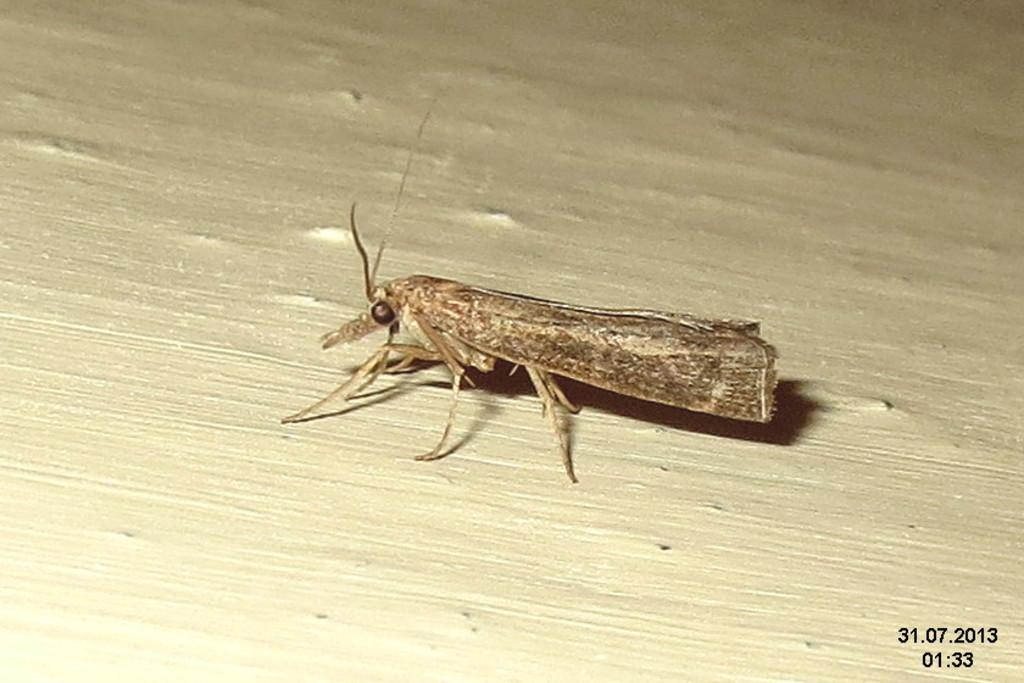What is the dog playing with in the garden? The dog is playing with a ball in the garden. What type of environment is the dog playing in? The dog is playing in a garden. What type of hands can be seen holding the ball in the image? There are no hands visible in the image; the dog is playing with the ball on its own. 